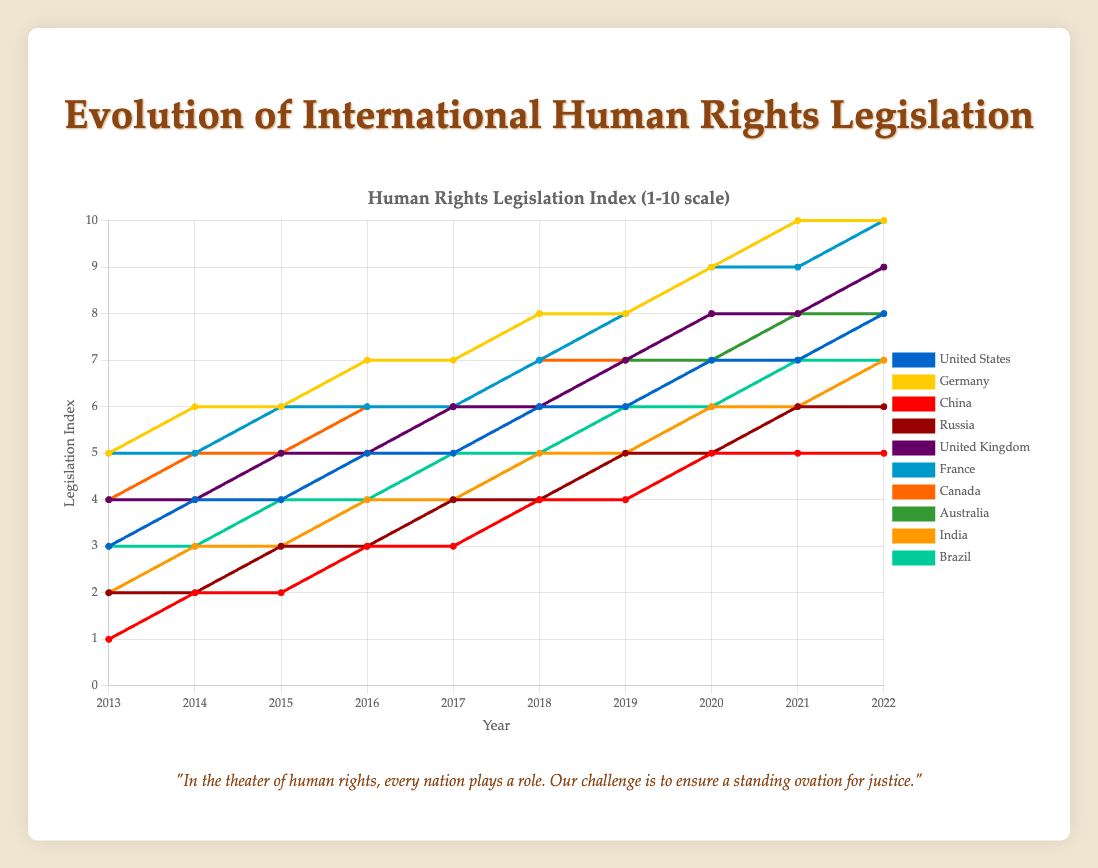What is the overall trend in human rights legislation for the United States from 2013 to 2022? Observing the line for the United States, the legislation index increases continuously from 3 in 2013 to 8 in 2022.
Answer: Continuous increase Which country had the highest human rights legislation index in 2022? In 2022, both Germany and France have the highest human rights legislation index of 10.
Answer: Germany and France Compare the human rights legislation index of China and India in 2015. Which country had a higher index? In 2015, China's human rights legislation index is 2, while India's is 3. Therefore, India's index is higher.
Answer: India How many countries reached a human rights legislation index of 6 by 2018? By 2018, the countries with an index of 6 are United States, Germany, Russia, United Kingdom, France, Canada, and Australia, which makes a total of 7 countries.
Answer: 7 What is the difference in the human rights legislation index between Brazil and Russia in 2022? In 2022, Brazil has an index of 7 whereas Russia has an index of 6. The difference between them is 7 - 6 = 1.
Answer: 1 On average, how much did Germany's human rights legislation index increase per year from 2013 to 2022? Germany's index increased from 5 in 2013 to 10 in 2022. The increase over 10 years is 10 - 5 = 5. The average annual increase is 5 / 10 = 0.5.
Answer: 0.5 Which country had the least improvement in its human rights legislation index over the entire period? China had the least improvement, its index increased from 1 in 2013 to 5 in 2022, which is an increment of 4.
Answer: China Compare the visual heights of bars for France and Canada in 2018. Which country had a higher index value? In 2018, France has a human rights legislation index of 7, while Canada has the same index value of 7. Thus, their visual heights are identical.
Answer: Identical Which countries had the same human rights legislation index in 2020? In 2020, the countries with an index of 7 are United States, United Kingdom, Canada, and Australia.
Answer: United States, United Kingdom, Canada, Australia What is the combined total human rights legislation index for United States, Germany, and China in 2022? In 2022, the United States has an index of 8, Germany has an index of 10, and China has an index of 5. The combined total is 8 + 10 + 5 = 23.
Answer: 23 